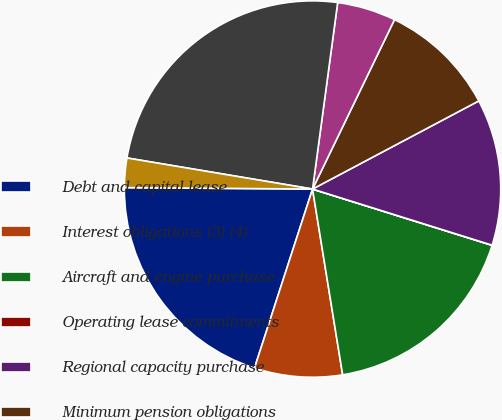Convert chart. <chart><loc_0><loc_0><loc_500><loc_500><pie_chart><fcel>Debt and capital lease<fcel>Interest obligations (3) (4)<fcel>Aircraft and engine purchase<fcel>Operating lease commitments<fcel>Regional capacity purchase<fcel>Minimum pension obligations<fcel>Retiree medical and other<fcel>Total American Contractual<fcel>Interest obligations (3)<nl><fcel>20.13%<fcel>7.55%<fcel>17.61%<fcel>0.01%<fcel>12.58%<fcel>10.07%<fcel>5.04%<fcel>24.49%<fcel>2.52%<nl></chart> 